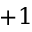Convert formula to latex. <formula><loc_0><loc_0><loc_500><loc_500>+ 1</formula> 